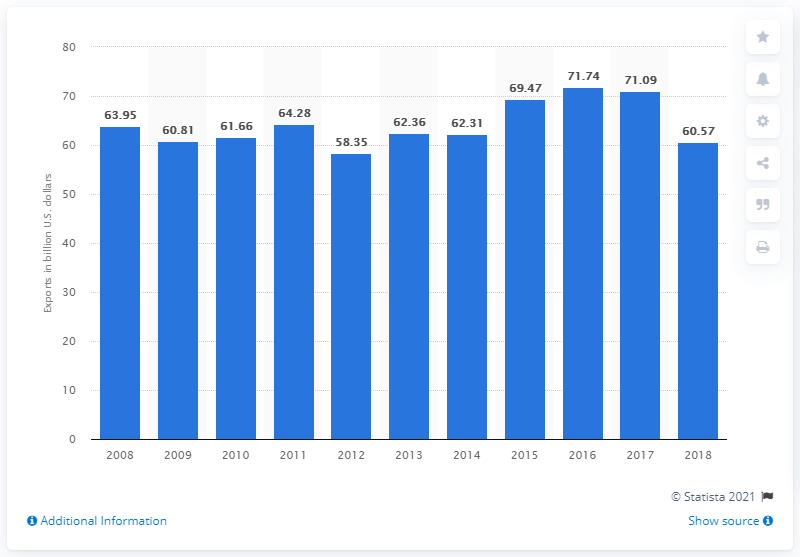Identify some key points in this picture. In 2018, the value of goods and services exported from Puerto Rico was approximately 60.57 billion dollars. 